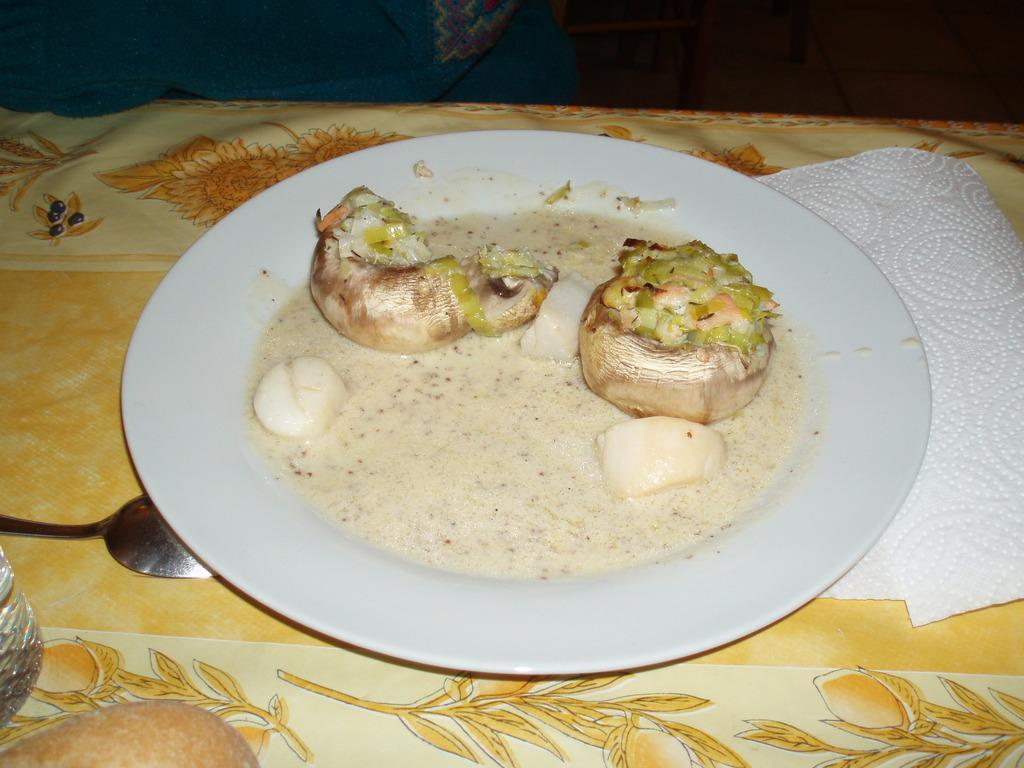How would you summarize this image in a sentence or two? There is a food item kept in a white color plate as we can see in the middle of this image. There is a spoon on the left side of this image and there is a tissue paper on the right side of this image. 